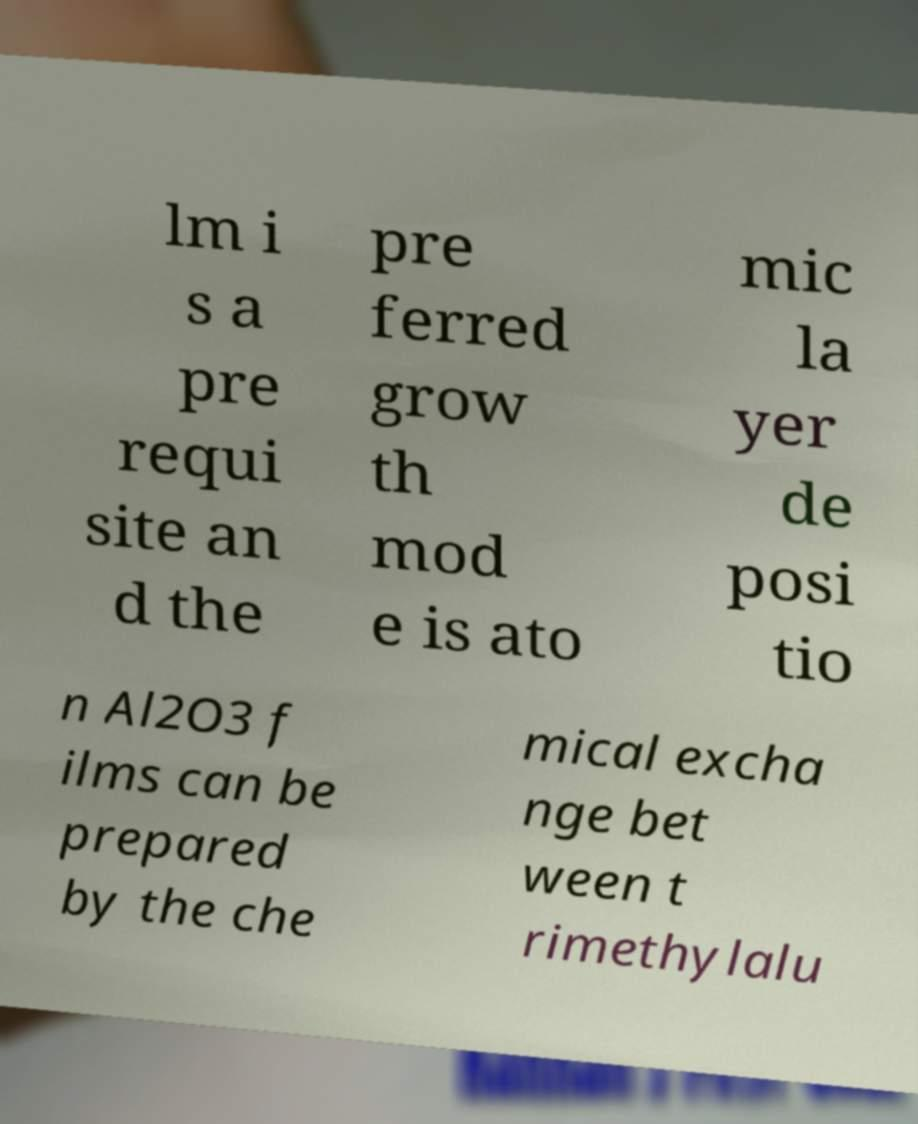There's text embedded in this image that I need extracted. Can you transcribe it verbatim? lm i s a pre requi site an d the pre ferred grow th mod e is ato mic la yer de posi tio n Al2O3 f ilms can be prepared by the che mical excha nge bet ween t rimethylalu 